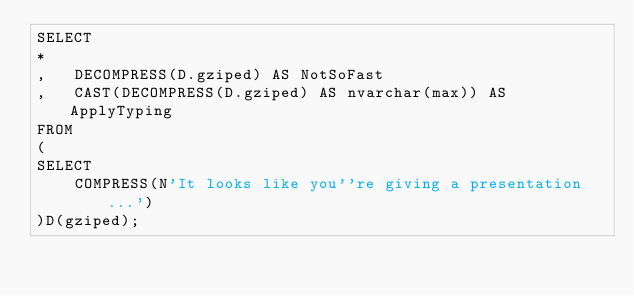Convert code to text. <code><loc_0><loc_0><loc_500><loc_500><_SQL_>SELECT
*
,   DECOMPRESS(D.gziped) AS NotSoFast
,   CAST(DECOMPRESS(D.gziped) AS nvarchar(max)) AS ApplyTyping
FROM
(
SELECT 
    COMPRESS(N'It looks like you''re giving a presentation...')
)D(gziped);</code> 